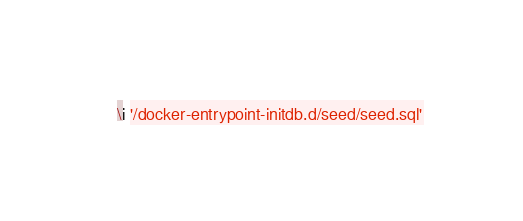<code> <loc_0><loc_0><loc_500><loc_500><_SQL_>
\i '/docker-entrypoint-initdb.d/seed/seed.sql'</code> 